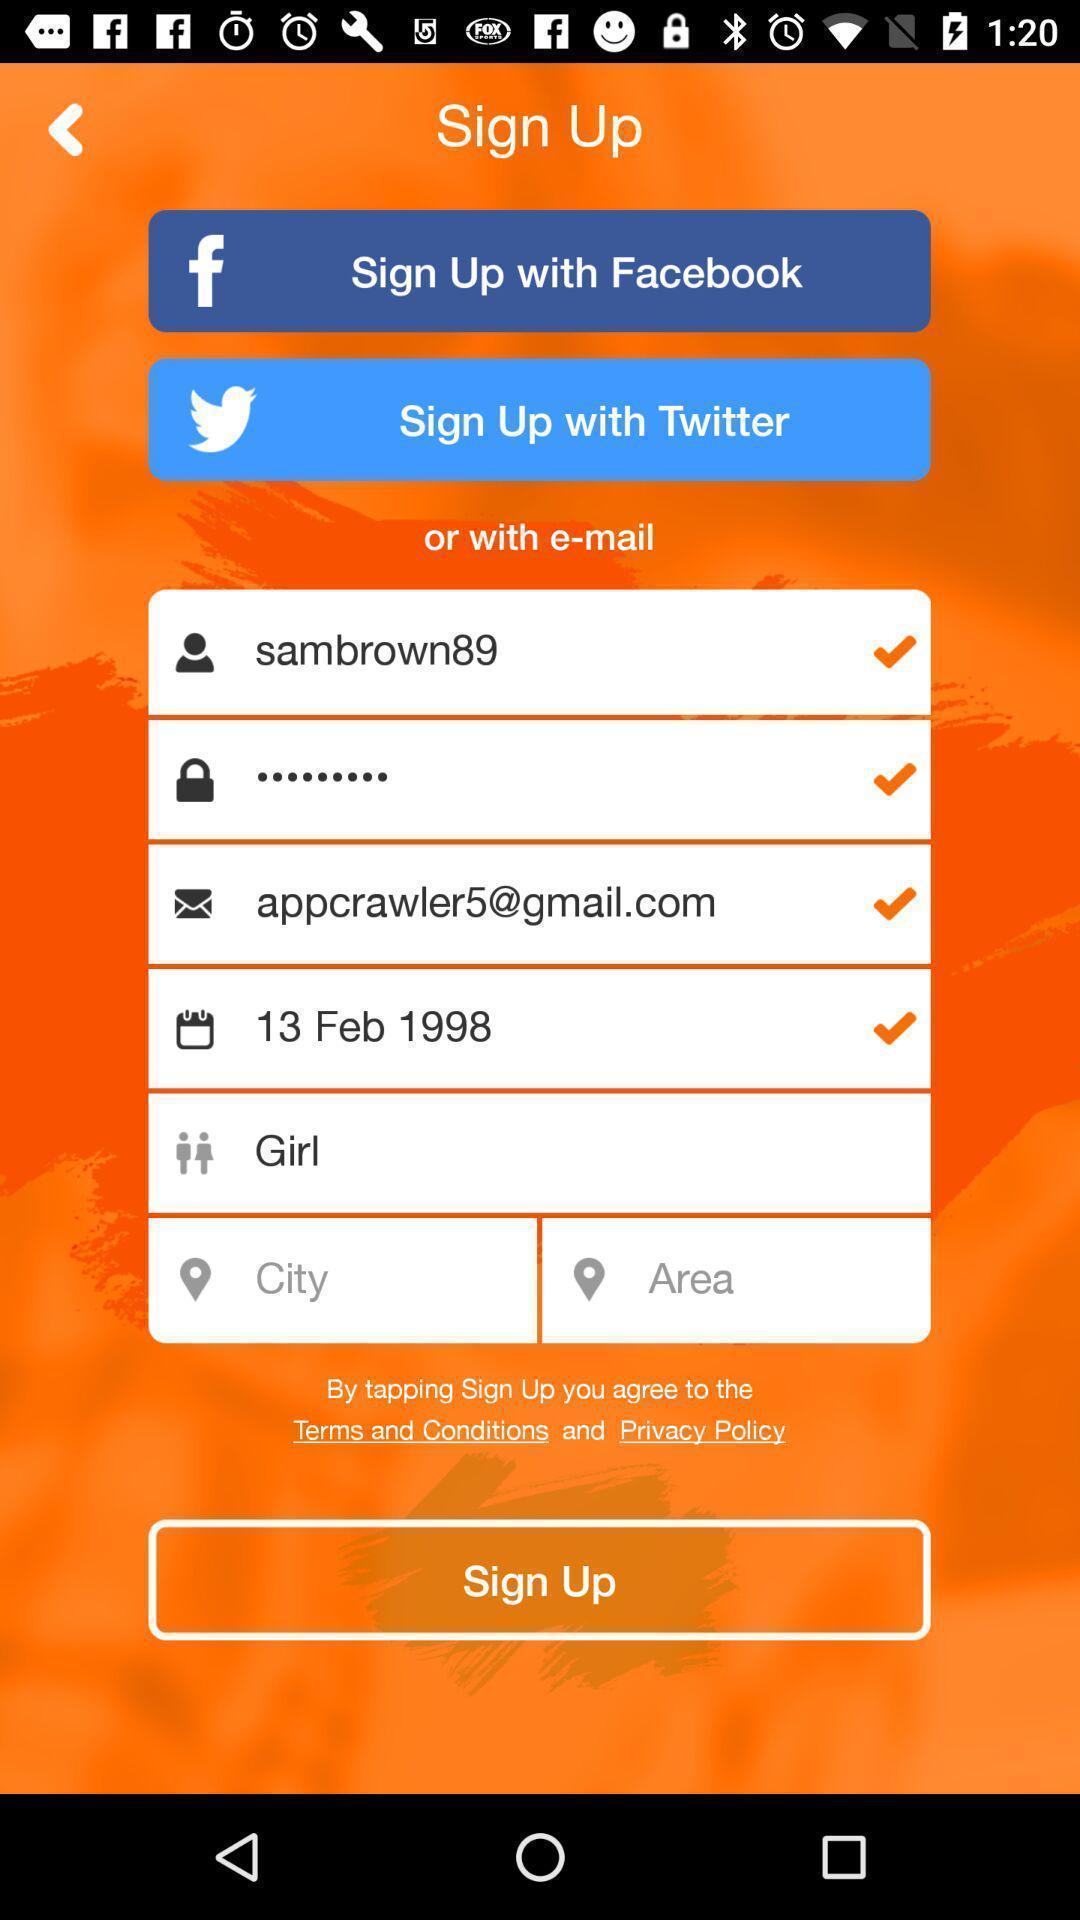Please provide a description for this image. Welcome to the sign up page. 